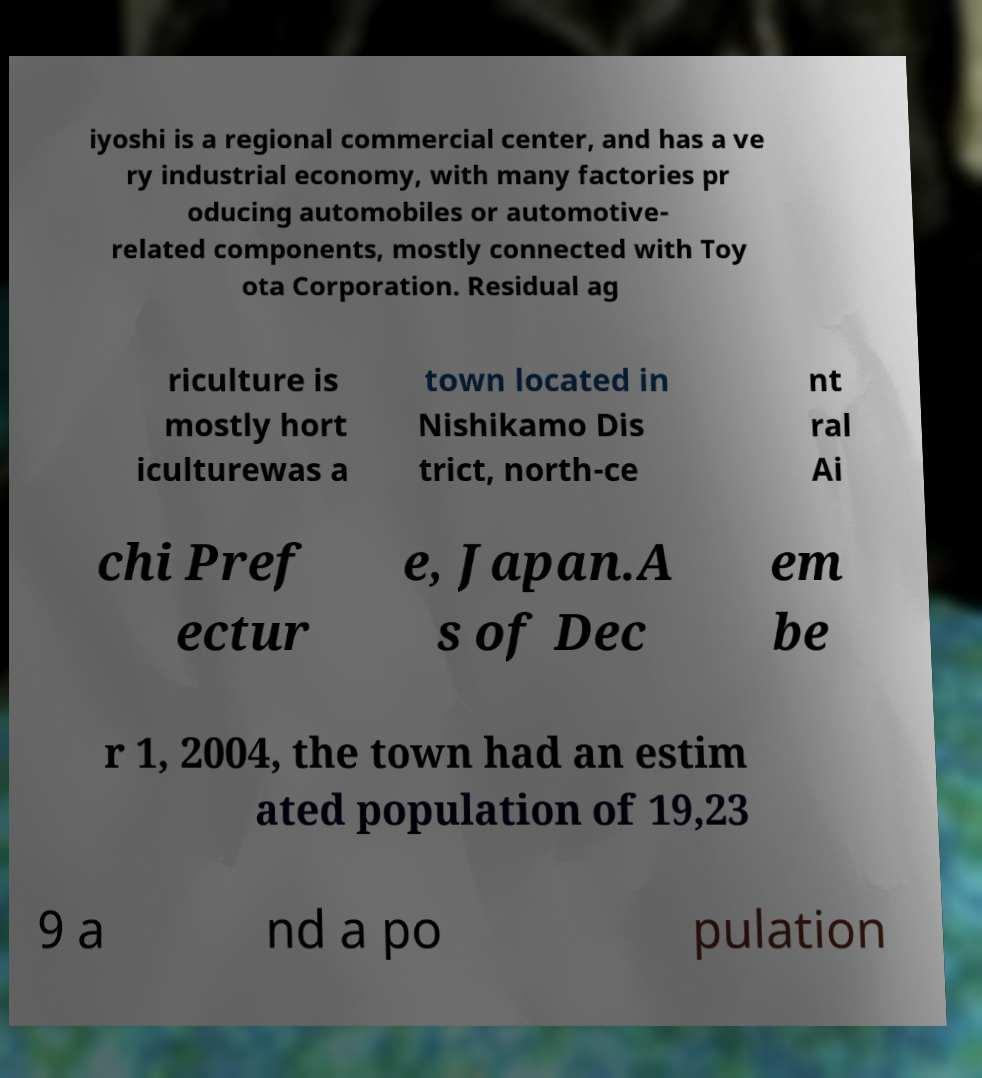Could you assist in decoding the text presented in this image and type it out clearly? iyoshi is a regional commercial center, and has a ve ry industrial economy, with many factories pr oducing automobiles or automotive- related components, mostly connected with Toy ota Corporation. Residual ag riculture is mostly hort iculturewas a town located in Nishikamo Dis trict, north-ce nt ral Ai chi Pref ectur e, Japan.A s of Dec em be r 1, 2004, the town had an estim ated population of 19,23 9 a nd a po pulation 